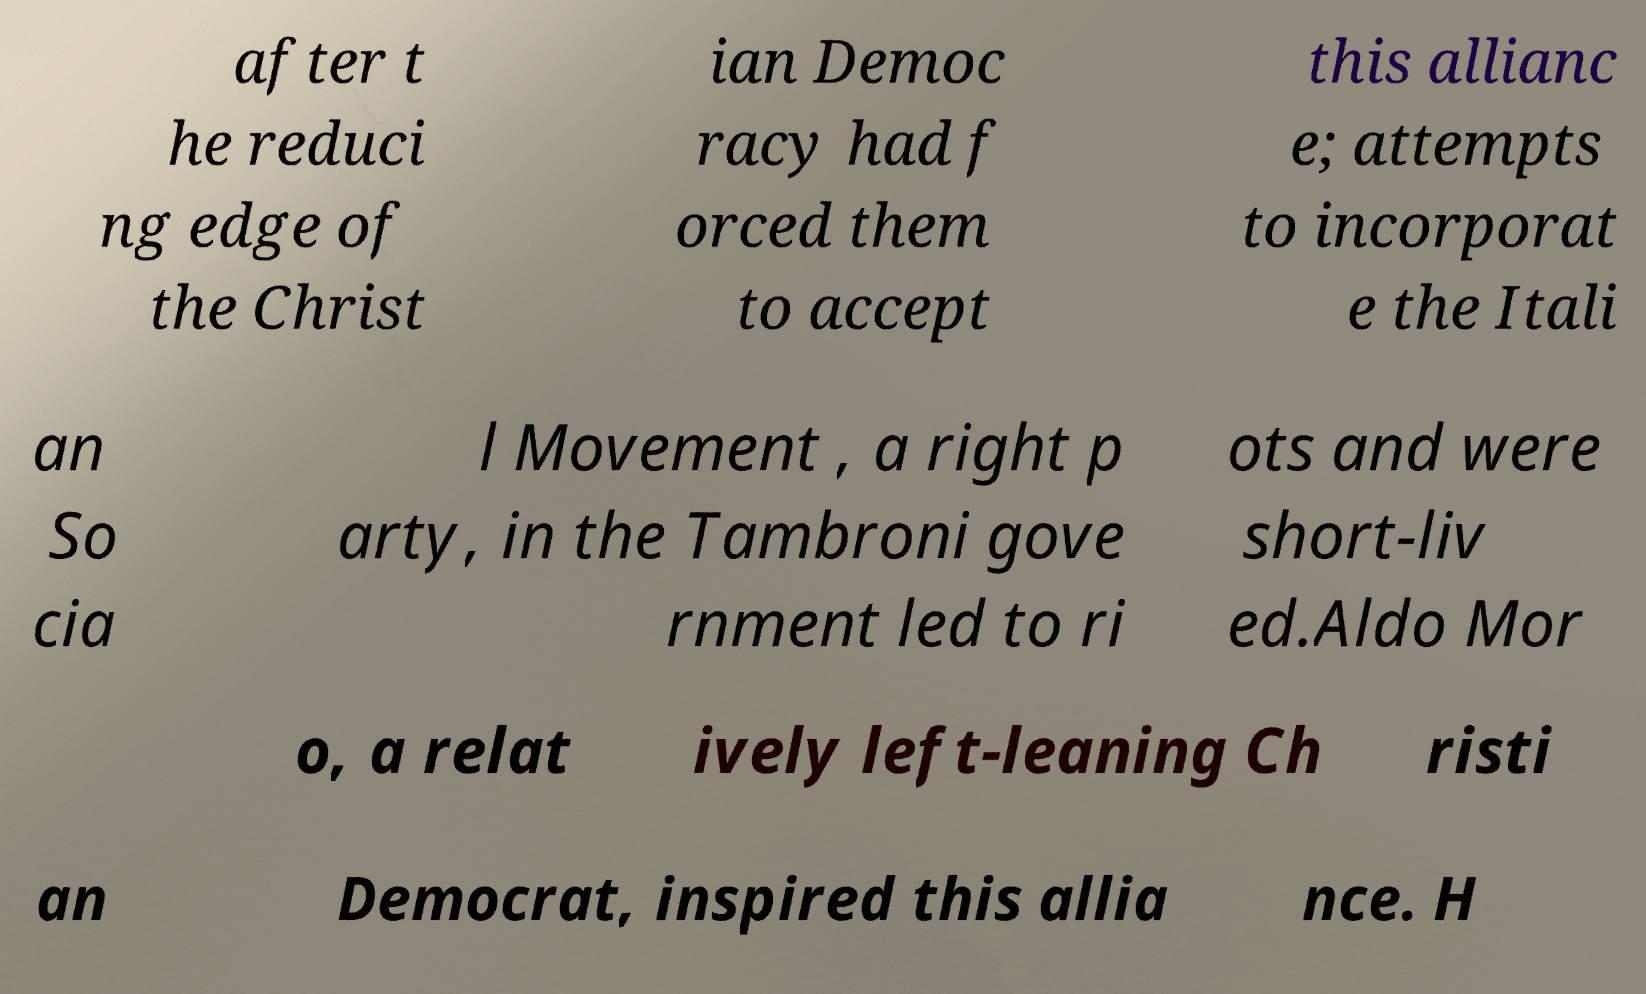Can you read and provide the text displayed in the image?This photo seems to have some interesting text. Can you extract and type it out for me? after t he reduci ng edge of the Christ ian Democ racy had f orced them to accept this allianc e; attempts to incorporat e the Itali an So cia l Movement , a right p arty, in the Tambroni gove rnment led to ri ots and were short-liv ed.Aldo Mor o, a relat ively left-leaning Ch risti an Democrat, inspired this allia nce. H 